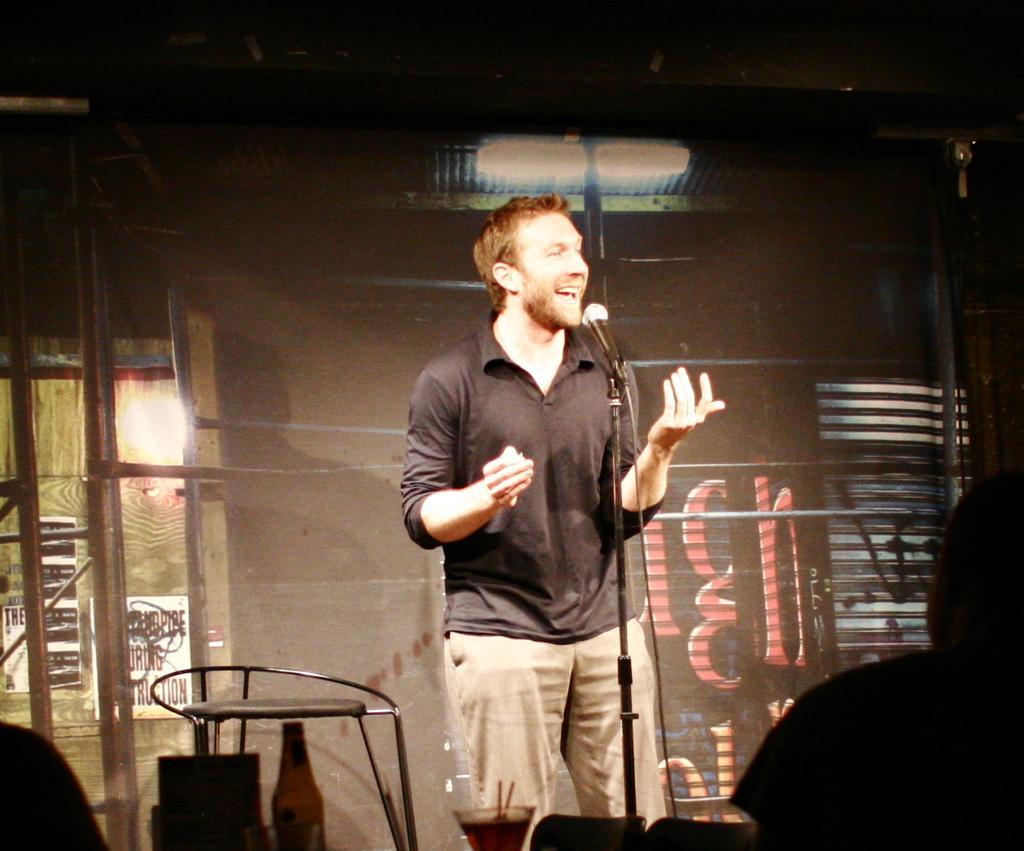Could you give a brief overview of what you see in this image? In this image I can see a person wearing black and cream colored dress is standing in front of a microphone. I can see a glass, a bottle and few persons. In the background I can see the wall, the ceiling, a light , the window and few metal rods. 